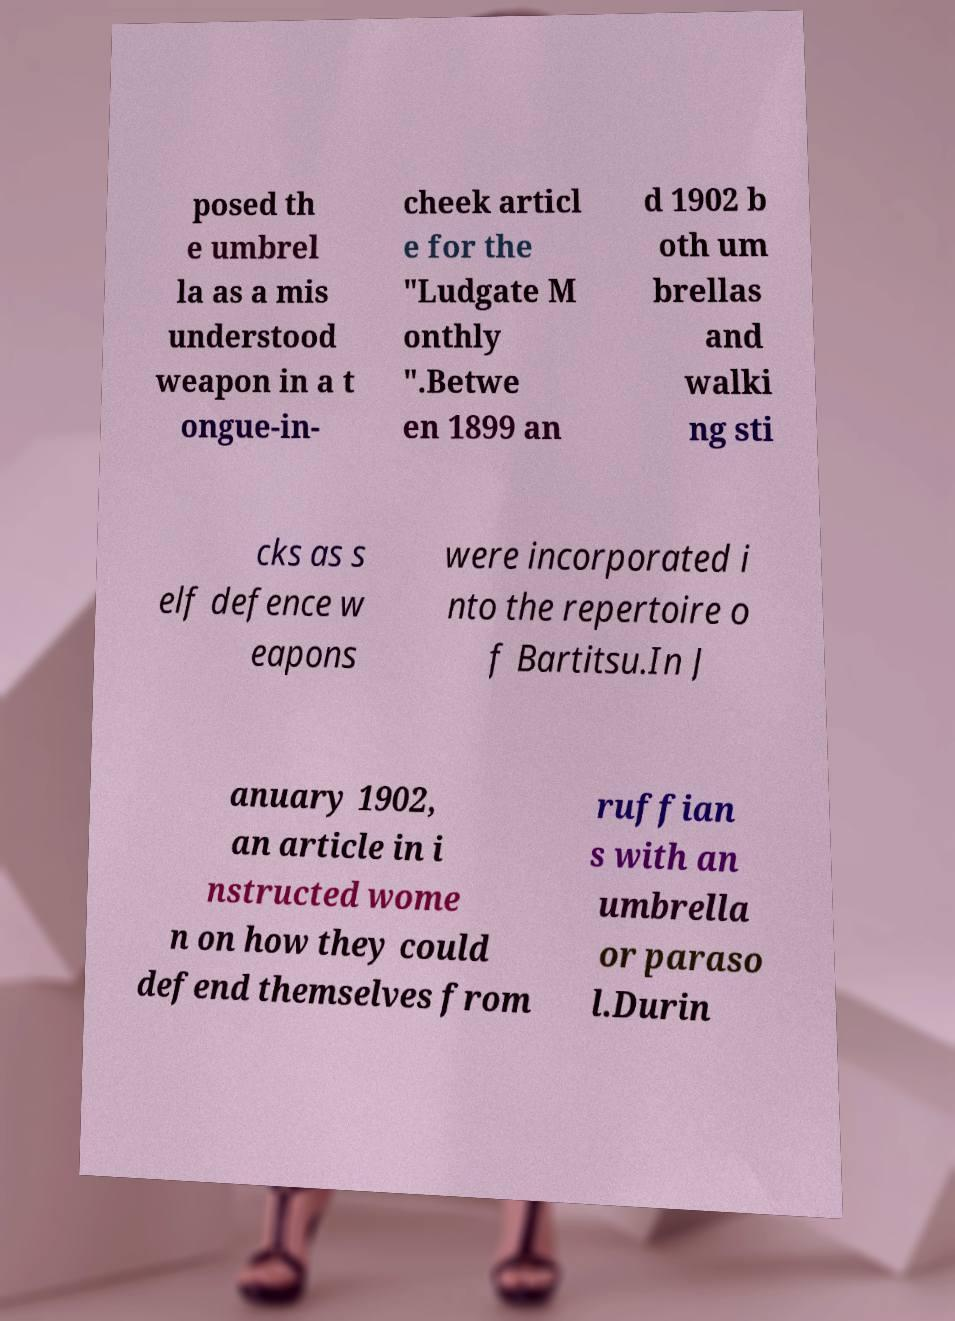For documentation purposes, I need the text within this image transcribed. Could you provide that? posed th e umbrel la as a mis understood weapon in a t ongue-in- cheek articl e for the "Ludgate M onthly ".Betwe en 1899 an d 1902 b oth um brellas and walki ng sti cks as s elf defence w eapons were incorporated i nto the repertoire o f Bartitsu.In J anuary 1902, an article in i nstructed wome n on how they could defend themselves from ruffian s with an umbrella or paraso l.Durin 